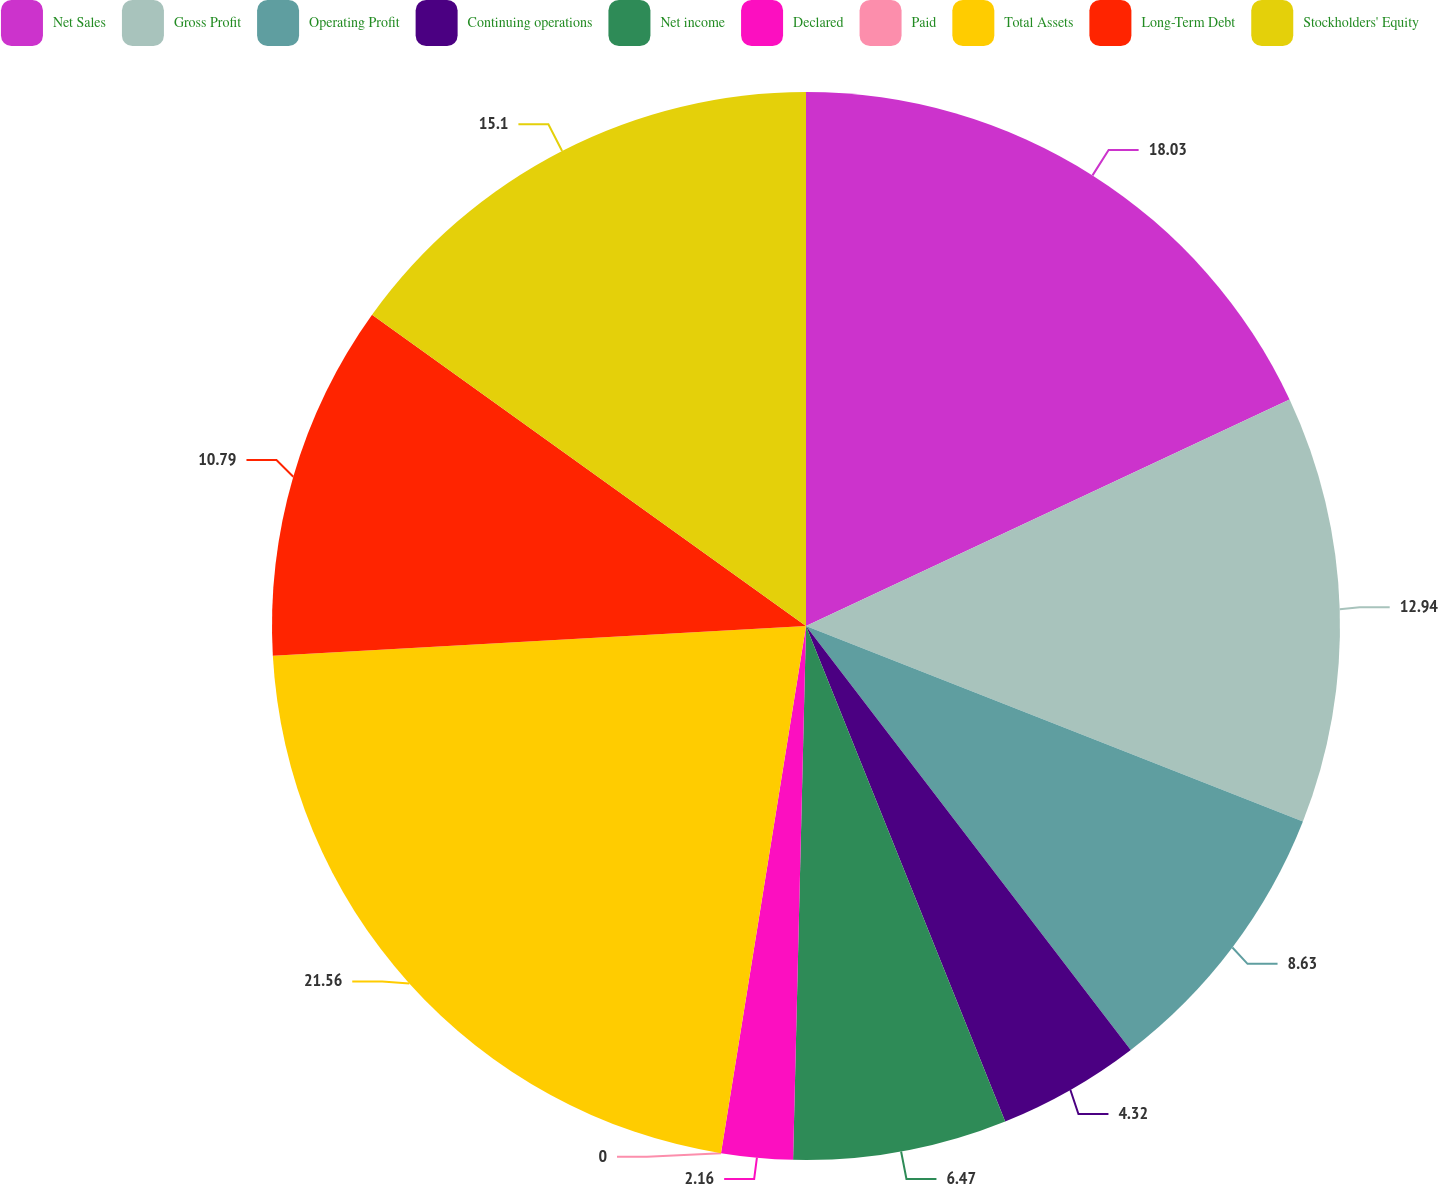Convert chart to OTSL. <chart><loc_0><loc_0><loc_500><loc_500><pie_chart><fcel>Net Sales<fcel>Gross Profit<fcel>Operating Profit<fcel>Continuing operations<fcel>Net income<fcel>Declared<fcel>Paid<fcel>Total Assets<fcel>Long-Term Debt<fcel>Stockholders' Equity<nl><fcel>18.03%<fcel>12.94%<fcel>8.63%<fcel>4.32%<fcel>6.47%<fcel>2.16%<fcel>0.0%<fcel>21.57%<fcel>10.79%<fcel>15.1%<nl></chart> 